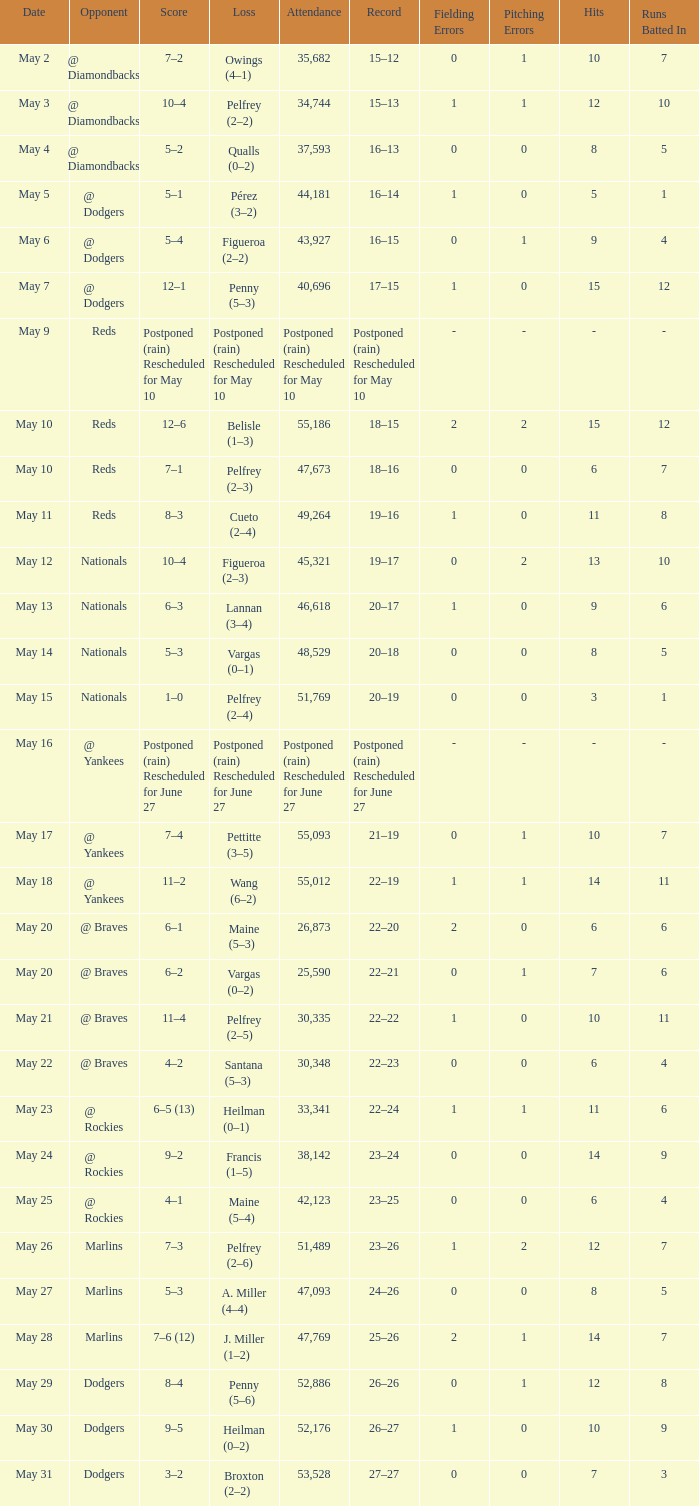Record of 22–20 involved what score? 6–1. 